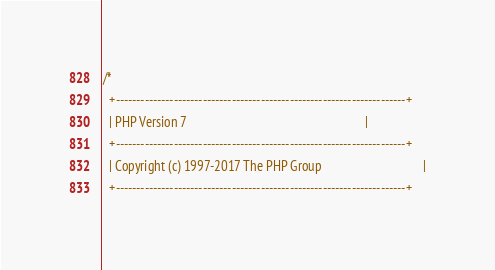<code> <loc_0><loc_0><loc_500><loc_500><_C_>/*
  +----------------------------------------------------------------------+
  | PHP Version 7                                                        |
  +----------------------------------------------------------------------+
  | Copyright (c) 1997-2017 The PHP Group                                |
  +----------------------------------------------------------------------+</code> 